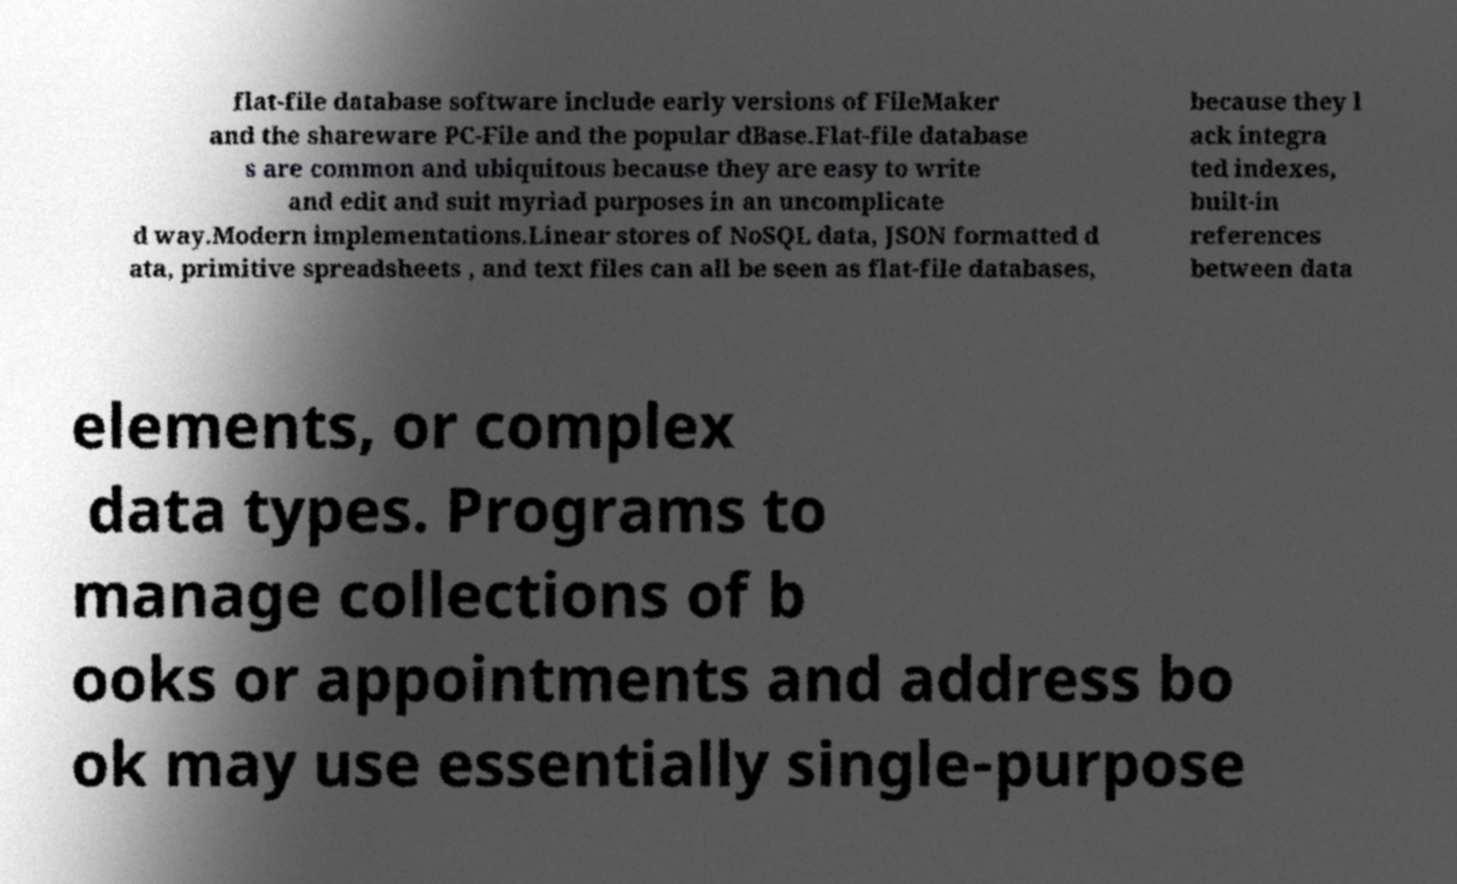For documentation purposes, I need the text within this image transcribed. Could you provide that? flat-file database software include early versions of FileMaker and the shareware PC-File and the popular dBase.Flat-file database s are common and ubiquitous because they are easy to write and edit and suit myriad purposes in an uncomplicate d way.Modern implementations.Linear stores of NoSQL data, JSON formatted d ata, primitive spreadsheets , and text files can all be seen as flat-file databases, because they l ack integra ted indexes, built-in references between data elements, or complex data types. Programs to manage collections of b ooks or appointments and address bo ok may use essentially single-purpose 